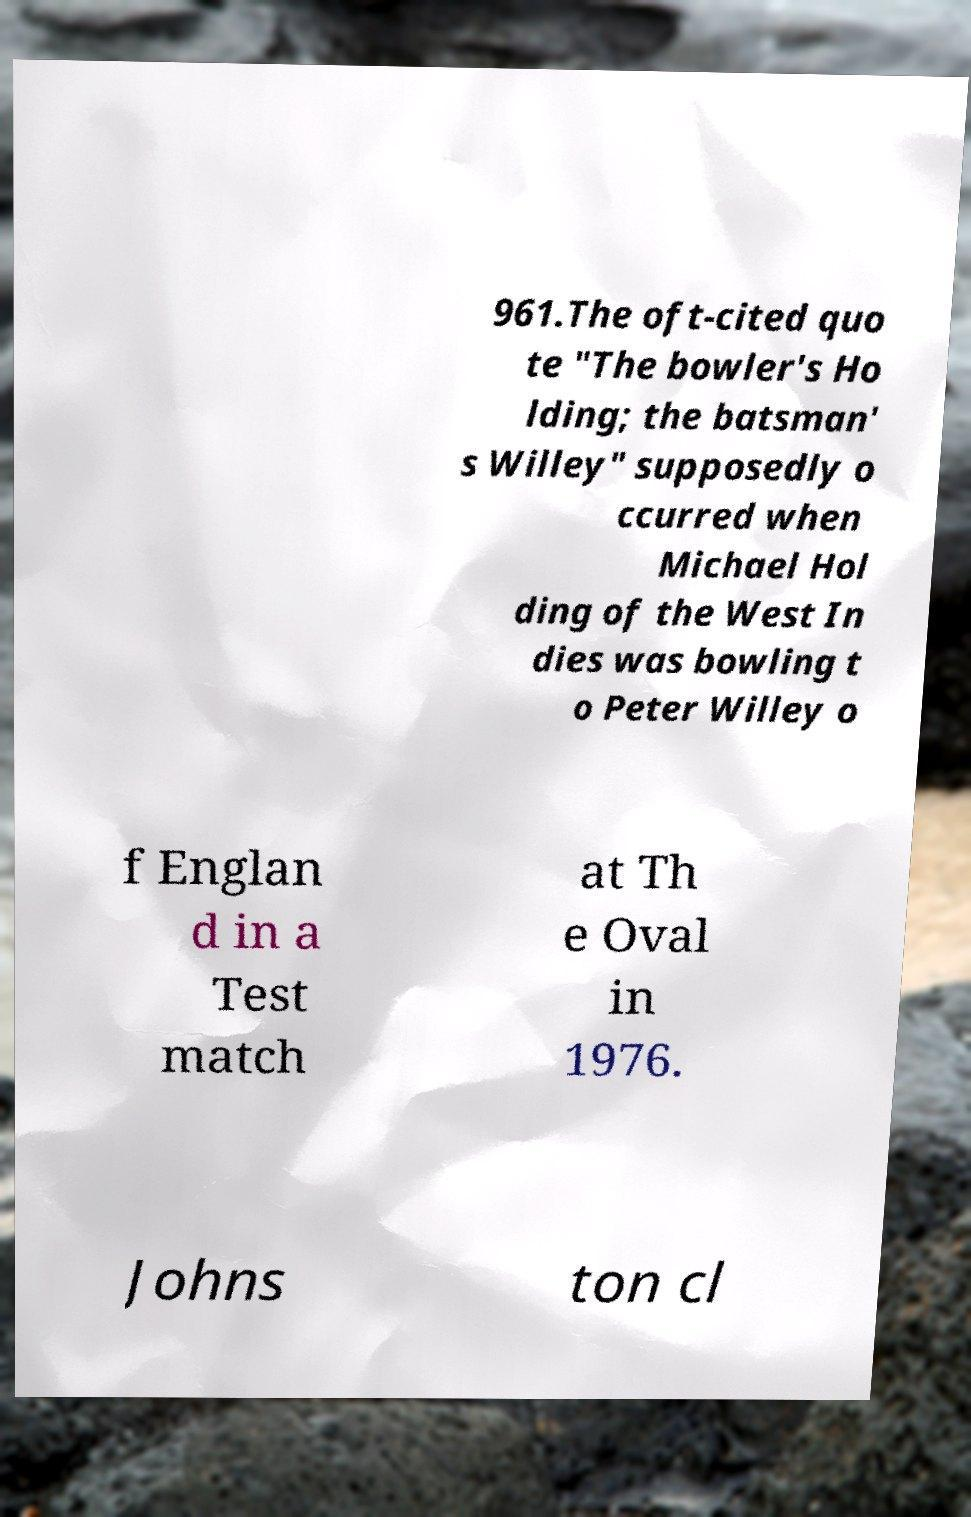Can you read and provide the text displayed in the image?This photo seems to have some interesting text. Can you extract and type it out for me? 961.The oft-cited quo te "The bowler's Ho lding; the batsman' s Willey" supposedly o ccurred when Michael Hol ding of the West In dies was bowling t o Peter Willey o f Englan d in a Test match at Th e Oval in 1976. Johns ton cl 